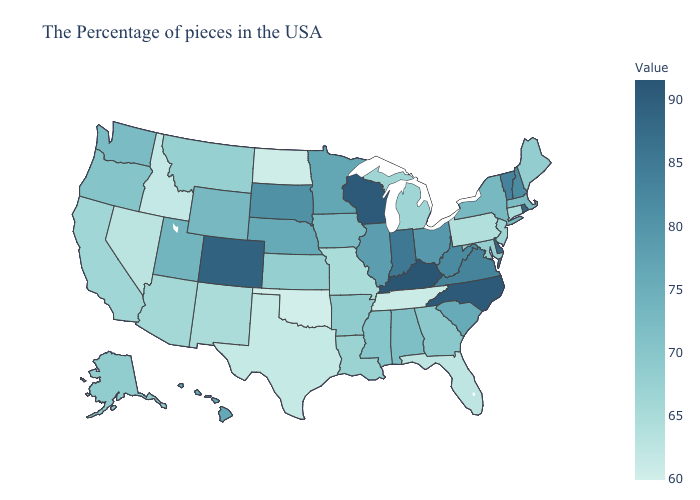Does Oklahoma have the lowest value in the South?
Quick response, please. Yes. Is the legend a continuous bar?
Concise answer only. Yes. Which states hav the highest value in the Northeast?
Quick response, please. Rhode Island. 